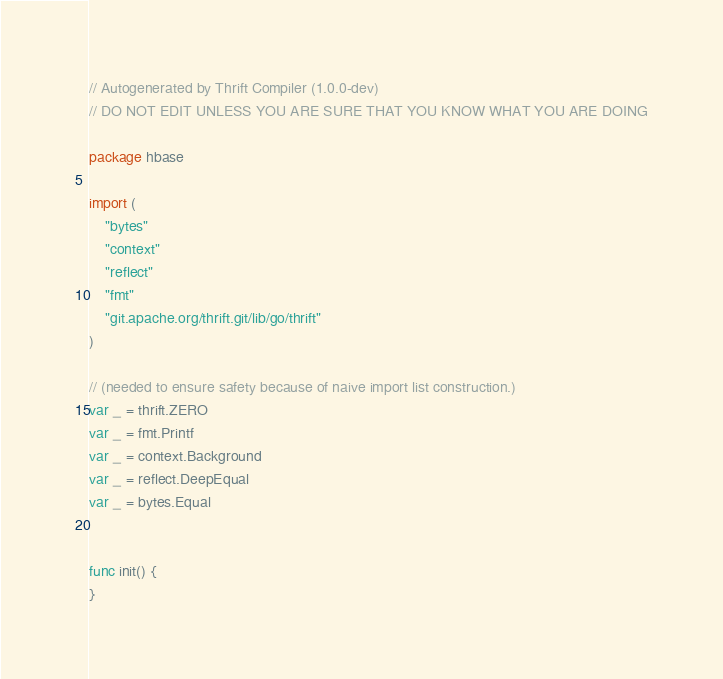<code> <loc_0><loc_0><loc_500><loc_500><_Go_>// Autogenerated by Thrift Compiler (1.0.0-dev)
// DO NOT EDIT UNLESS YOU ARE SURE THAT YOU KNOW WHAT YOU ARE DOING

package hbase

import (
	"bytes"
	"context"
	"reflect"
	"fmt"
	"git.apache.org/thrift.git/lib/go/thrift"
)

// (needed to ensure safety because of naive import list construction.)
var _ = thrift.ZERO
var _ = fmt.Printf
var _ = context.Background
var _ = reflect.DeepEqual
var _ = bytes.Equal


func init() {
}

</code> 